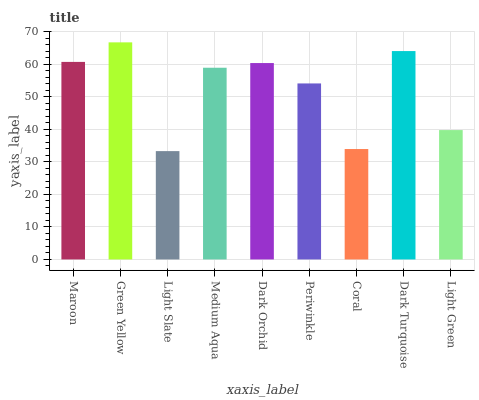Is Light Slate the minimum?
Answer yes or no. Yes. Is Green Yellow the maximum?
Answer yes or no. Yes. Is Green Yellow the minimum?
Answer yes or no. No. Is Light Slate the maximum?
Answer yes or no. No. Is Green Yellow greater than Light Slate?
Answer yes or no. Yes. Is Light Slate less than Green Yellow?
Answer yes or no. Yes. Is Light Slate greater than Green Yellow?
Answer yes or no. No. Is Green Yellow less than Light Slate?
Answer yes or no. No. Is Medium Aqua the high median?
Answer yes or no. Yes. Is Medium Aqua the low median?
Answer yes or no. Yes. Is Dark Orchid the high median?
Answer yes or no. No. Is Dark Orchid the low median?
Answer yes or no. No. 